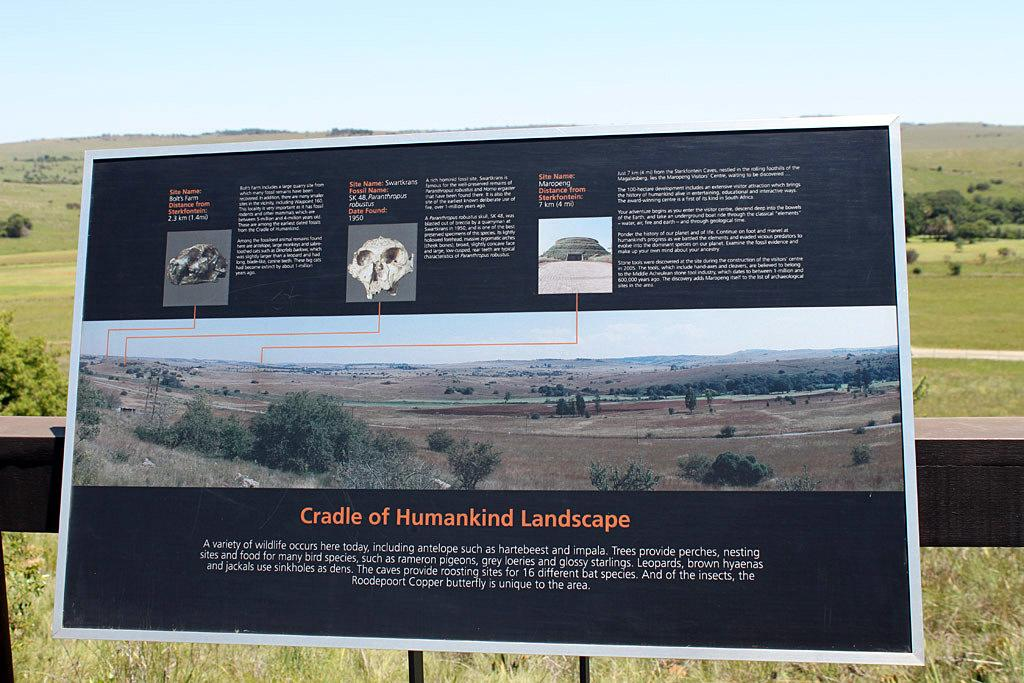<image>
Summarize the visual content of the image. Cradle of Humankind landscape poster on the outside 